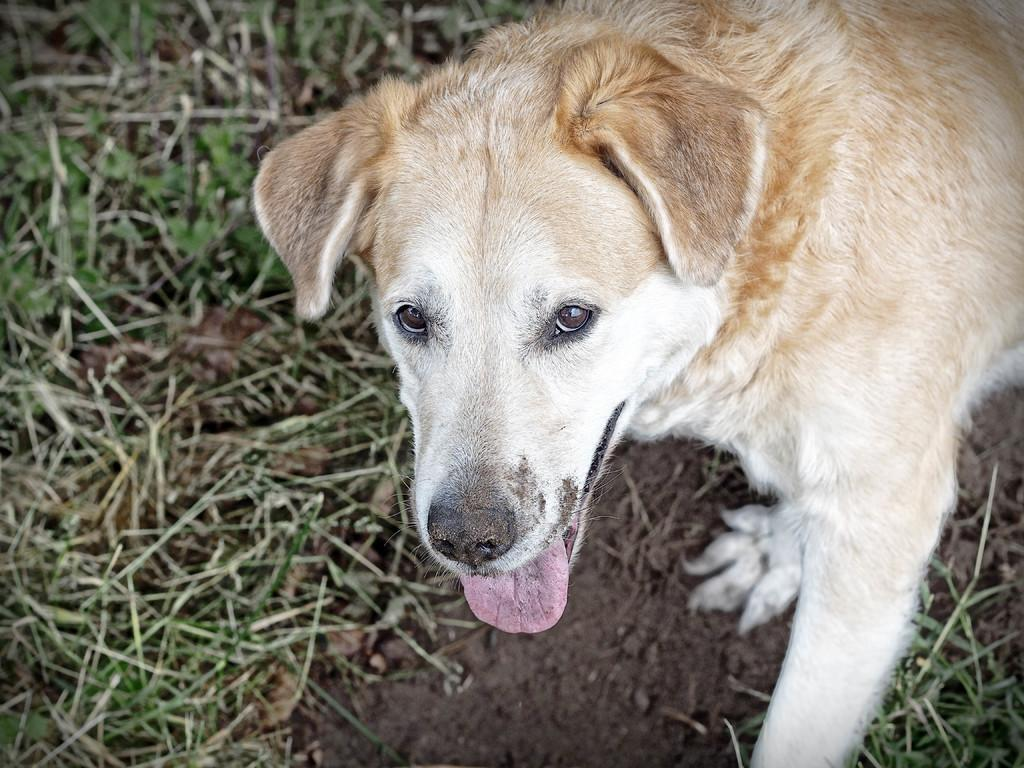What type of animal is present in the image? There is a dog in the image. What type of natural environment is visible at the bottom of the image? There is grass visible at the bottom of the image. What type of jar can be seen in the image? There is no jar present in the image. How many bears are visible in the image? There are no bears visible in the image. 